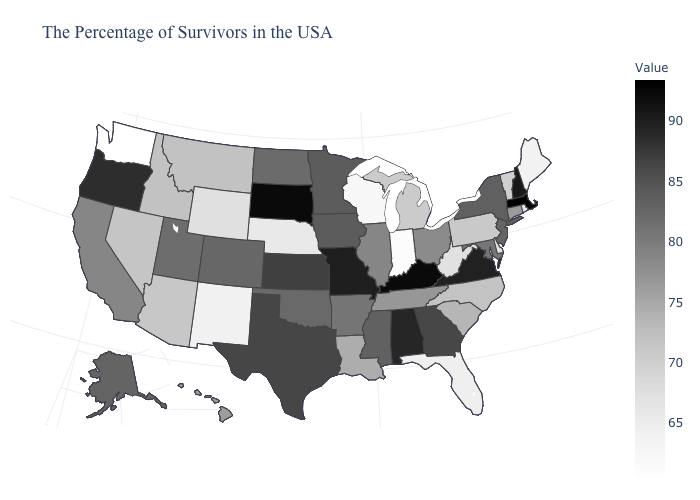Among the states that border Tennessee , which have the lowest value?
Concise answer only. North Carolina. Does Massachusetts have the highest value in the USA?
Give a very brief answer. Yes. Which states have the highest value in the USA?
Write a very short answer. Massachusetts. Does Oklahoma have the lowest value in the South?
Write a very short answer. No. Does Indiana have the lowest value in the USA?
Give a very brief answer. No. 